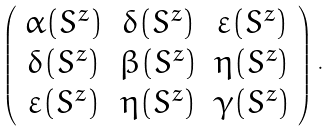<formula> <loc_0><loc_0><loc_500><loc_500>\left ( \begin{array} { c c c } \alpha ( S ^ { z } ) & \delta ( S ^ { z } ) & \varepsilon ( S ^ { z } ) \\ \delta ( S ^ { z } ) & \beta ( S ^ { z } ) & \eta ( S ^ { z } ) \\ \varepsilon ( S ^ { z } ) & \eta ( S ^ { z } ) & \gamma ( S ^ { z } ) \end{array} \right ) \, .</formula> 